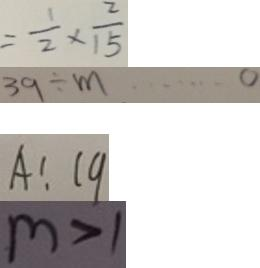Convert formula to latex. <formula><loc_0><loc_0><loc_500><loc_500>= \frac { 1 } { 2 } \times \frac { 2 } { 1 5 } 
 3 9 \div m \cdots 0 
 A : 1 9 
 m > 1</formula> 